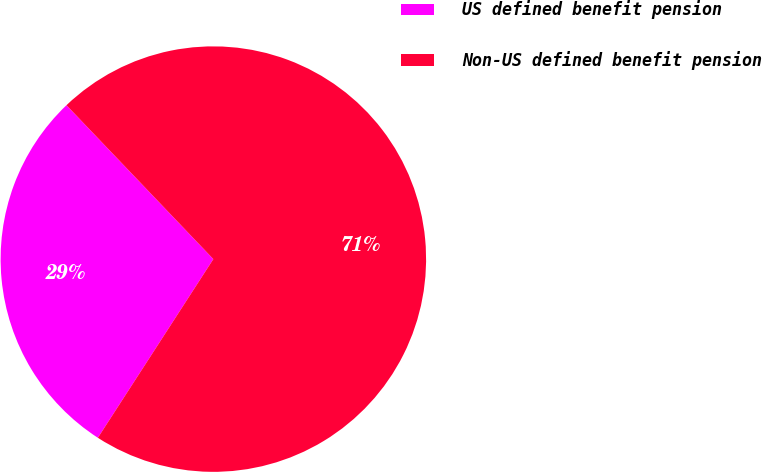Convert chart. <chart><loc_0><loc_0><loc_500><loc_500><pie_chart><fcel>US defined benefit pension<fcel>Non-US defined benefit pension<nl><fcel>28.74%<fcel>71.26%<nl></chart> 